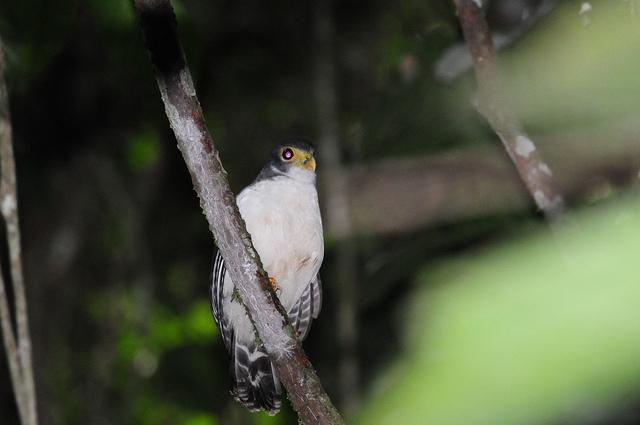What color is the bird's breast?
Answer briefly. White. Is this a baby hawk?
Keep it brief. Yes. Is this a daytime scene?
Be succinct. No. Is it night time?
Short answer required. Yes. What type of bird is in the tree?
Be succinct. White and black one. Is it a sunny day?
Answer briefly. No. Is it day time or night time?
Concise answer only. Night. 